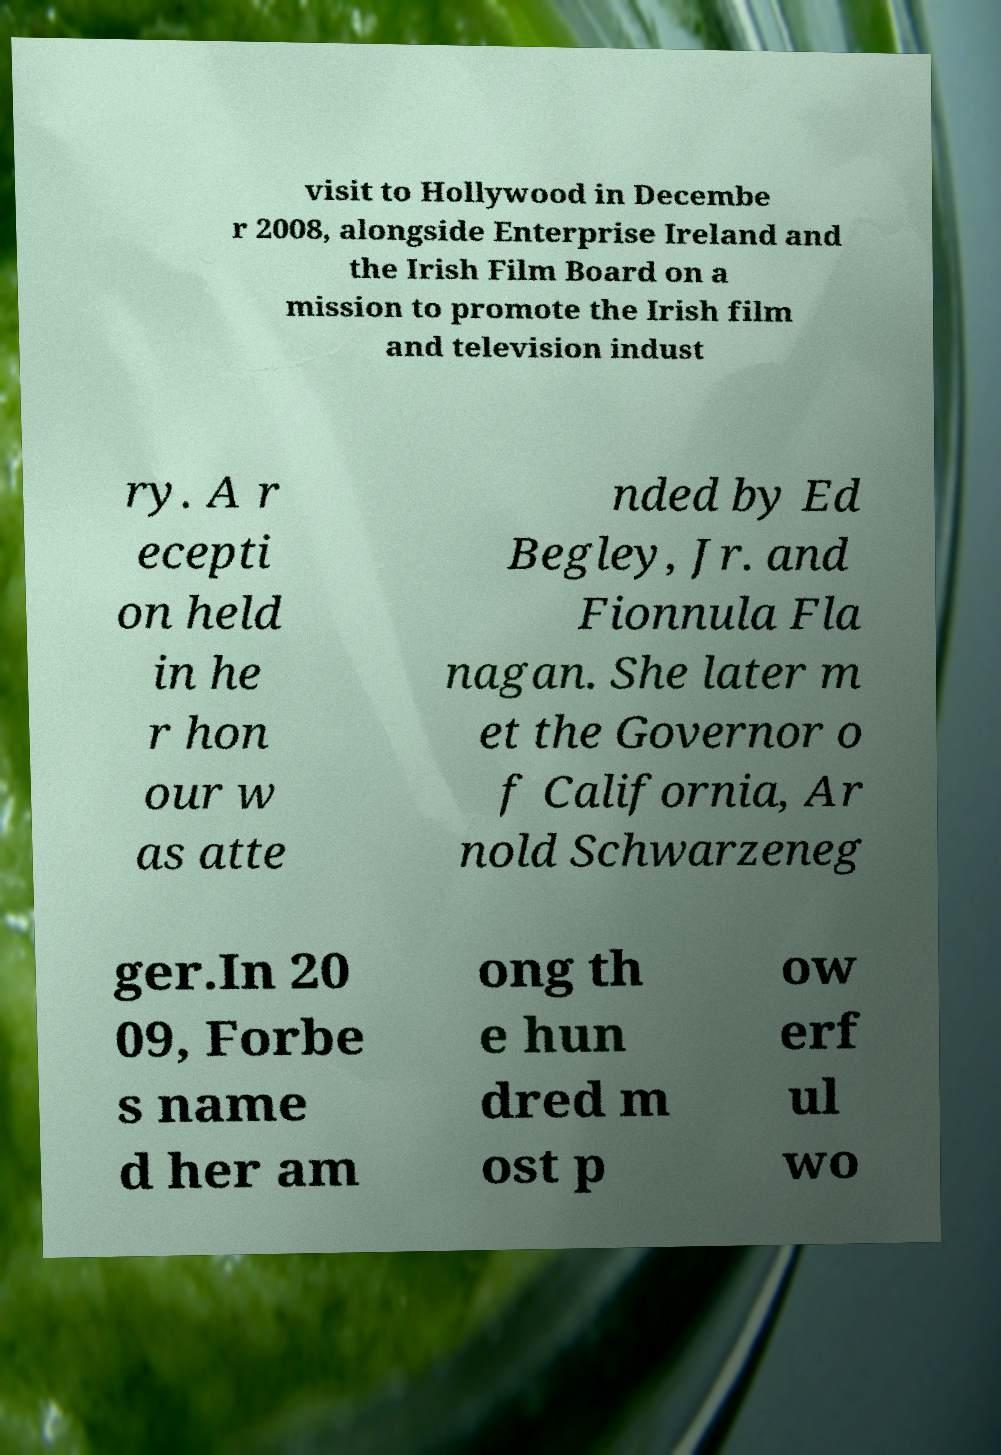There's text embedded in this image that I need extracted. Can you transcribe it verbatim? visit to Hollywood in Decembe r 2008, alongside Enterprise Ireland and the Irish Film Board on a mission to promote the Irish film and television indust ry. A r ecepti on held in he r hon our w as atte nded by Ed Begley, Jr. and Fionnula Fla nagan. She later m et the Governor o f California, Ar nold Schwarzeneg ger.In 20 09, Forbe s name d her am ong th e hun dred m ost p ow erf ul wo 